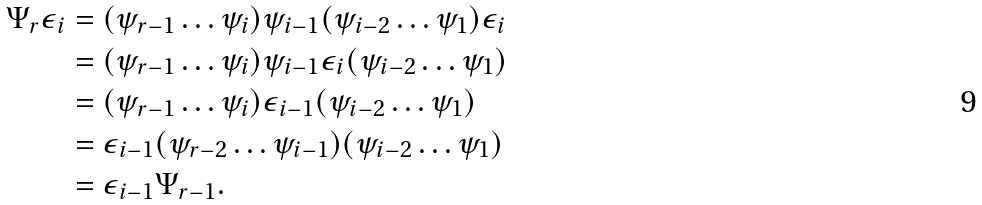<formula> <loc_0><loc_0><loc_500><loc_500>\Psi _ { r } \epsilon _ { i } & = ( \psi _ { r - 1 } \dots \psi _ { i } ) \psi _ { i - 1 } ( \psi _ { i - 2 } \dots \psi _ { 1 } ) \epsilon _ { i } \\ & = ( \psi _ { r - 1 } \dots \psi _ { i } ) \psi _ { i - 1 } \epsilon _ { i } ( \psi _ { i - 2 } \dots \psi _ { 1 } ) \\ & = ( \psi _ { r - 1 } \dots \psi _ { i } ) \epsilon _ { i - 1 } ( \psi _ { i - 2 } \dots \psi _ { 1 } ) \\ & = \epsilon _ { i - 1 } ( \psi _ { r - 2 } \dots \psi _ { i - 1 } ) ( \psi _ { i - 2 } \dots \psi _ { 1 } ) \\ & = \epsilon _ { i - 1 } \Psi _ { r - 1 } .</formula> 